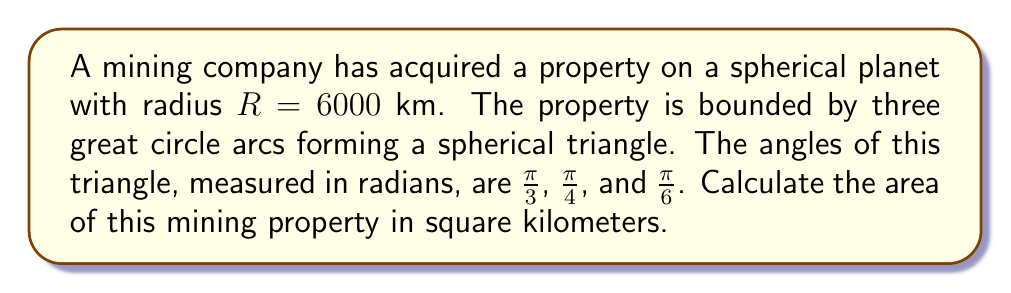Provide a solution to this math problem. To solve this problem, we'll use the formula for the area of a spherical triangle on a sphere of radius $R$:

$$A = (α + β + γ - π)R^2$$

Where $A$ is the area, $R$ is the radius of the sphere, and $α$, $β$, and $γ$ are the angles of the spherical triangle.

Step 1: Sum the given angles
$$α + β + γ = \frac{\pi}{3} + \frac{\pi}{4} + \frac{\pi}{6} = \frac{4\pi}{12} + \frac{3\pi}{12} + \frac{2\pi}{12} = \frac{9\pi}{12} = \frac{3\pi}{4}$$

Step 2: Subtract $π$ from the sum
$$\frac{3\pi}{4} - π = -\frac{\pi}{4}$$

Step 3: Multiply by $R^2$
$$A = -\frac{\pi}{4} * (6000 \text{ km})^2 = -\frac{\pi}{4} * 36,000,000 \text{ km}^2$$

Step 4: Calculate the final result
$$A = -28,274,333.88... \text{ km}^2$$

The negative sign indicates that the area is on the other side of the sphere. We take the absolute value for the final answer.

Step 5: Round to the nearest whole number
$$A ≈ 28,274,334 \text{ km}^2$$
Answer: 28,274,334 km² 